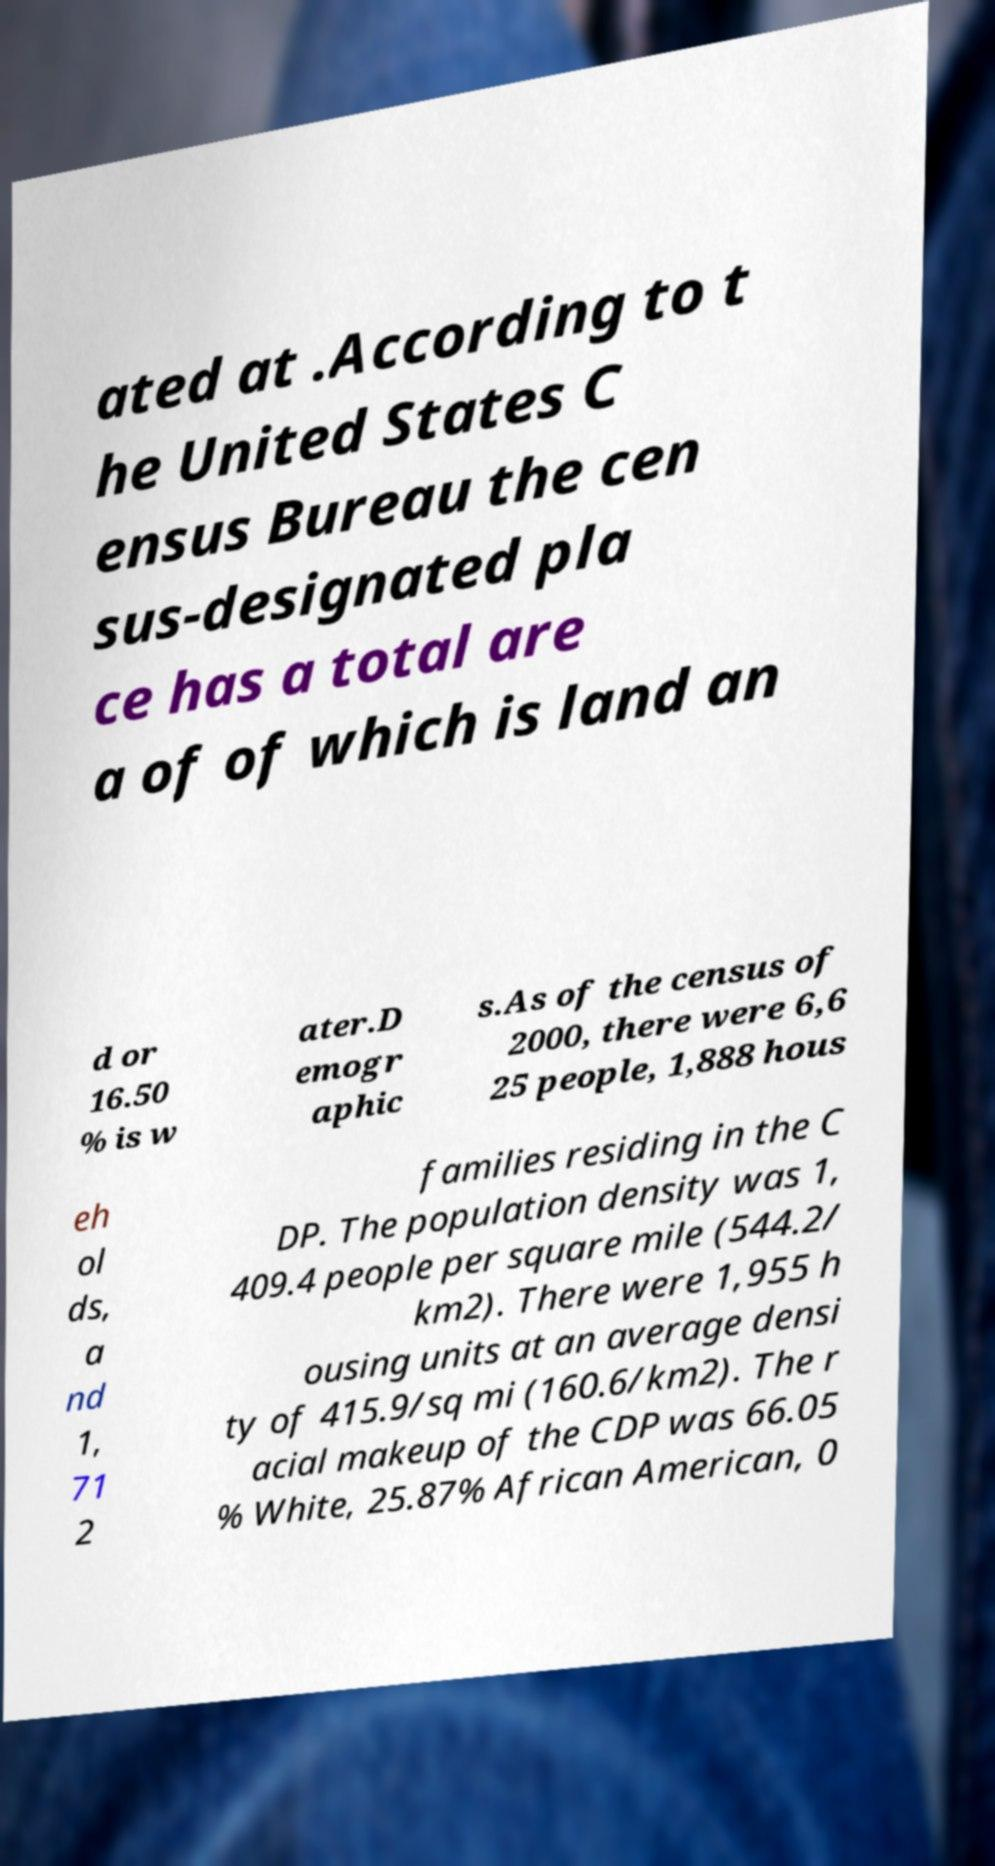For documentation purposes, I need the text within this image transcribed. Could you provide that? ated at .According to t he United States C ensus Bureau the cen sus-designated pla ce has a total are a of of which is land an d or 16.50 % is w ater.D emogr aphic s.As of the census of 2000, there were 6,6 25 people, 1,888 hous eh ol ds, a nd 1, 71 2 families residing in the C DP. The population density was 1, 409.4 people per square mile (544.2/ km2). There were 1,955 h ousing units at an average densi ty of 415.9/sq mi (160.6/km2). The r acial makeup of the CDP was 66.05 % White, 25.87% African American, 0 